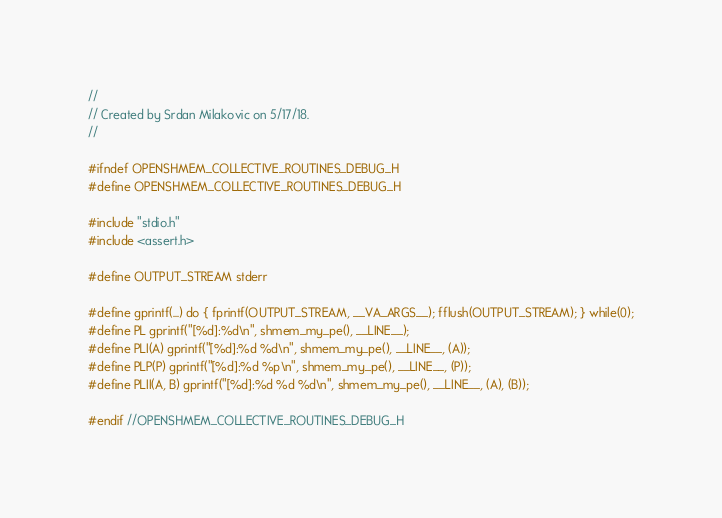<code> <loc_0><loc_0><loc_500><loc_500><_C_>//
// Created by Srdan Milakovic on 5/17/18.
//

#ifndef OPENSHMEM_COLLECTIVE_ROUTINES_DEBUG_H
#define OPENSHMEM_COLLECTIVE_ROUTINES_DEBUG_H

#include "stdio.h"
#include <assert.h>

#define OUTPUT_STREAM stderr

#define gprintf(...) do { fprintf(OUTPUT_STREAM, __VA_ARGS__); fflush(OUTPUT_STREAM); } while(0);
#define PL gprintf("[%d]:%d\n", shmem_my_pe(), __LINE__);
#define PLI(A) gprintf("[%d]:%d %d\n", shmem_my_pe(), __LINE__, (A));
#define PLP(P) gprintf("[%d]:%d %p\n", shmem_my_pe(), __LINE__, (P));
#define PLII(A, B) gprintf("[%d]:%d %d %d\n", shmem_my_pe(), __LINE__, (A), (B));

#endif //OPENSHMEM_COLLECTIVE_ROUTINES_DEBUG_H
</code> 